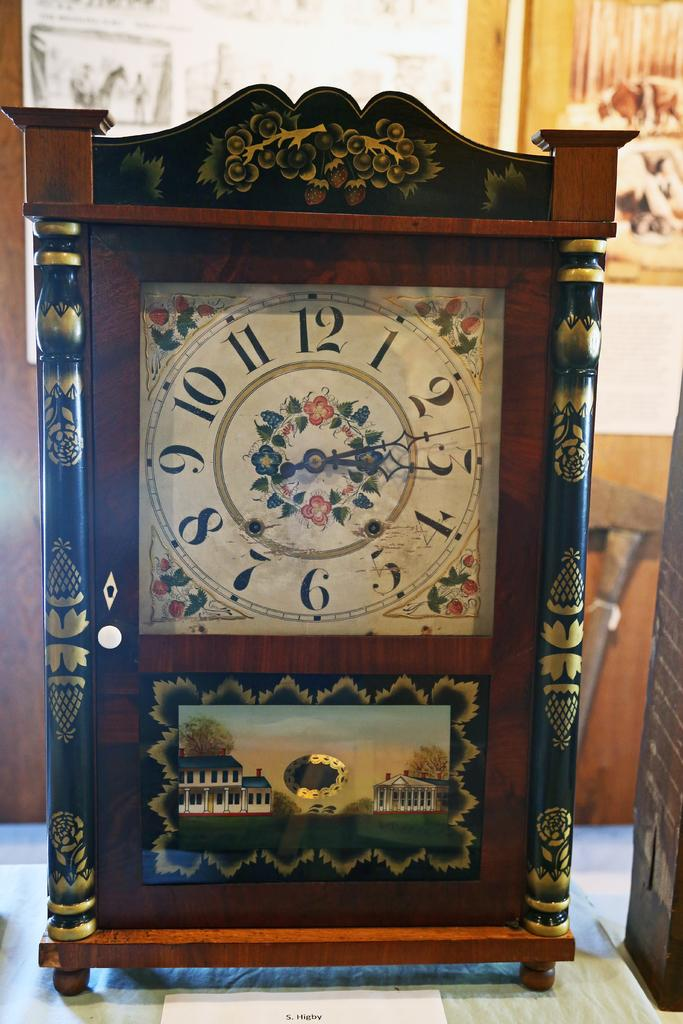<image>
Summarize the visual content of the image. A very decorative vintage looking clock shows that the time is almost 3:15. 